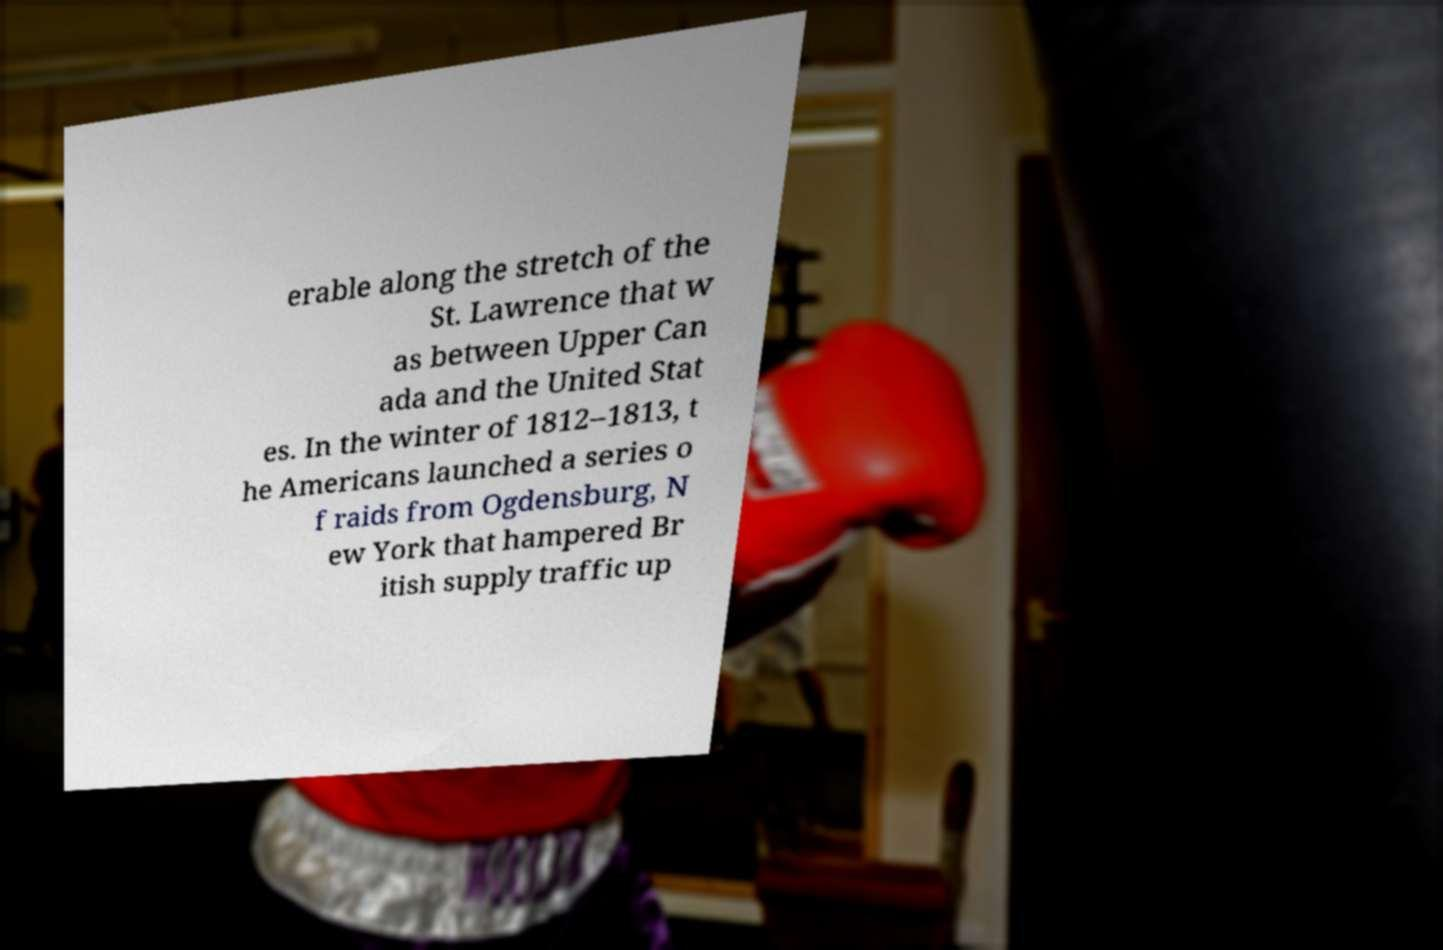Please identify and transcribe the text found in this image. erable along the stretch of the St. Lawrence that w as between Upper Can ada and the United Stat es. In the winter of 1812–1813, t he Americans launched a series o f raids from Ogdensburg, N ew York that hampered Br itish supply traffic up 